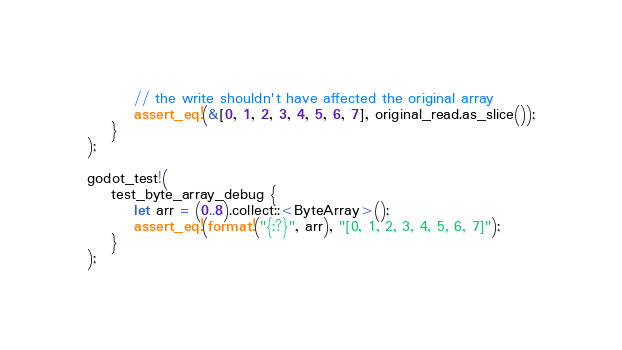<code> <loc_0><loc_0><loc_500><loc_500><_Rust_>
        // the write shouldn't have affected the original array
        assert_eq!(&[0, 1, 2, 3, 4, 5, 6, 7], original_read.as_slice());
    }
);

godot_test!(
    test_byte_array_debug {
        let arr = (0..8).collect::<ByteArray>();
        assert_eq!(format!("{:?}", arr), "[0, 1, 2, 3, 4, 5, 6, 7]");
    }
);
</code> 